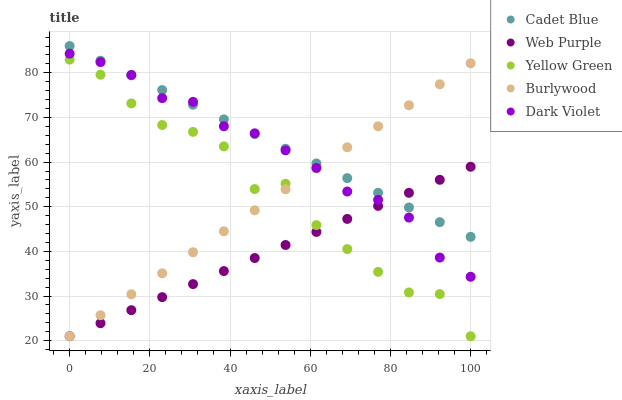Does Web Purple have the minimum area under the curve?
Answer yes or no. Yes. Does Cadet Blue have the maximum area under the curve?
Answer yes or no. Yes. Does Cadet Blue have the minimum area under the curve?
Answer yes or no. No. Does Web Purple have the maximum area under the curve?
Answer yes or no. No. Is Burlywood the smoothest?
Answer yes or no. Yes. Is Yellow Green the roughest?
Answer yes or no. Yes. Is Web Purple the smoothest?
Answer yes or no. No. Is Web Purple the roughest?
Answer yes or no. No. Does Burlywood have the lowest value?
Answer yes or no. Yes. Does Cadet Blue have the lowest value?
Answer yes or no. No. Does Cadet Blue have the highest value?
Answer yes or no. Yes. Does Web Purple have the highest value?
Answer yes or no. No. Is Yellow Green less than Cadet Blue?
Answer yes or no. Yes. Is Dark Violet greater than Yellow Green?
Answer yes or no. Yes. Does Web Purple intersect Yellow Green?
Answer yes or no. Yes. Is Web Purple less than Yellow Green?
Answer yes or no. No. Is Web Purple greater than Yellow Green?
Answer yes or no. No. Does Yellow Green intersect Cadet Blue?
Answer yes or no. No. 